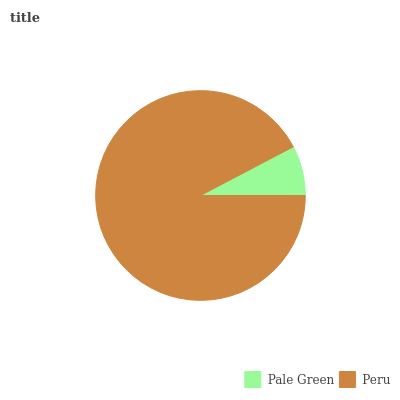Is Pale Green the minimum?
Answer yes or no. Yes. Is Peru the maximum?
Answer yes or no. Yes. Is Peru the minimum?
Answer yes or no. No. Is Peru greater than Pale Green?
Answer yes or no. Yes. Is Pale Green less than Peru?
Answer yes or no. Yes. Is Pale Green greater than Peru?
Answer yes or no. No. Is Peru less than Pale Green?
Answer yes or no. No. Is Peru the high median?
Answer yes or no. Yes. Is Pale Green the low median?
Answer yes or no. Yes. Is Pale Green the high median?
Answer yes or no. No. Is Peru the low median?
Answer yes or no. No. 